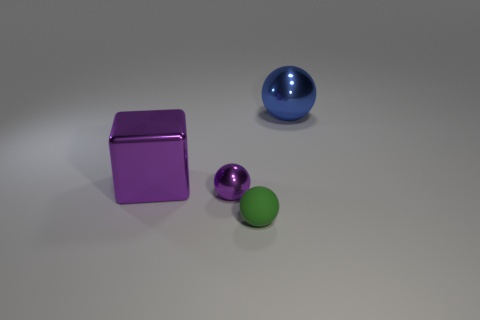There is a large metal thing left of the object that is on the right side of the green rubber object; what shape is it?
Offer a terse response. Cube. Does the tiny green object have the same shape as the large shiny thing that is on the left side of the small green rubber thing?
Keep it short and to the point. No. How many big purple blocks are right of the big metallic thing in front of the blue sphere?
Offer a very short reply. 0. What material is the purple thing that is the same shape as the green matte object?
Keep it short and to the point. Metal. How many brown things are large spheres or tiny rubber objects?
Your response must be concise. 0. Are there any other things of the same color as the rubber object?
Keep it short and to the point. No. What color is the big metallic ball right of the metallic ball in front of the big metallic sphere?
Make the answer very short. Blue. Are there fewer small rubber spheres that are on the left side of the large shiny block than balls left of the big shiny ball?
Your answer should be compact. Yes. There is a tiny sphere that is the same color as the large metallic block; what is it made of?
Provide a succinct answer. Metal. How many objects are either metallic objects to the left of the large blue shiny thing or small shiny objects?
Ensure brevity in your answer.  2. 